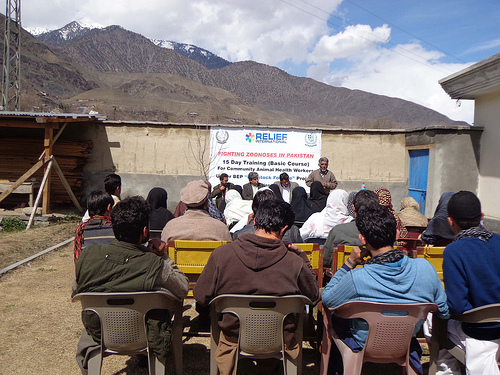<image>
Is the man in front of the hat man? No. The man is not in front of the hat man. The spatial positioning shows a different relationship between these objects. 